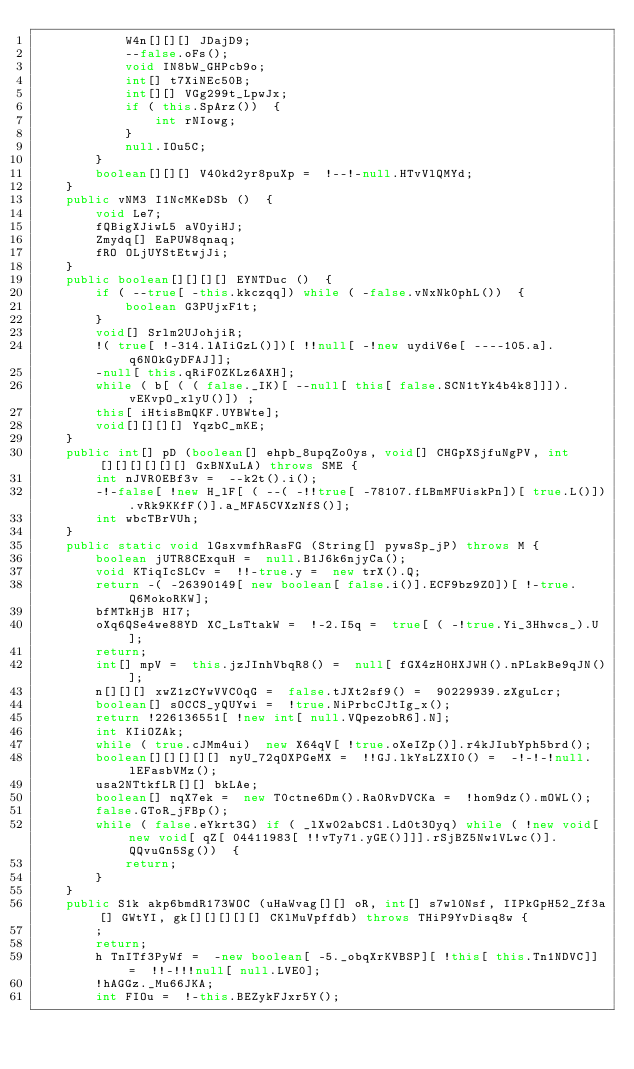Convert code to text. <code><loc_0><loc_0><loc_500><loc_500><_Java_>            W4n[][][] JDajD9;
            --false.oFs();
            void IN8bW_GHPcb9o;
            int[] t7XiNEc50B;
            int[][] VGg299t_LpwJx;
            if ( this.SpArz())  {
                int rNIowg;
            }
            null.IOu5C;
        }
        boolean[][][] V40kd2yr8puXp =  !--!-null.HTvVlQMYd;
    }
    public vNM3 I1NcMKeDSb ()  {
        void Le7;
        fQBigXJiwL5 aVOyiHJ;
        Zmydq[] EaPUW8qnaq;
        fRO OLjUYStEtwjJi;
    }
    public boolean[][][][] EYNTDuc ()  {
        if ( --true[ -this.kkczqq]) while ( -false.vNxNk0phL())  {
            boolean G3PUjxF1t;
        }
        void[] Srlm2UJohjiR;
        !( true[ !-314.lAIiGzL()])[ !!null[ -!new uydiV6e[ ----105.a].q6NOkGyDFAJ]];
        -null[ this.qRiF0ZKLz6AXH];
        while ( b[ ( ( false._IK)[ --null[ this[ false.SCN1tYk4b4k8]]]).vEKvpO_xlyU()]) ;
        this[ iHtisBmQKF.UYBWte];
        void[][][][] YqzbC_mKE;
    }
    public int[] pD (boolean[] ehpb_8upqZo0ys, void[] CHGpXSjfuNgPV, int[][][][][][] GxBNXuLA) throws SME {
        int nJVR0EBf3v =  --k2t().i();
        -!-false[ !new H_lF[ ( --( -!!true[ -78107.fLBmMFUiskPn])[ true.L()]).vRk9KKfF()].a_MFA5CVXzNfS()];
        int wbcTBrVUh;
    }
    public static void lGsxvmfhRasFG (String[] pywsSp_jP) throws M {
        boolean jUTR8CExquH =  null.B1J6k6njyCa();
        void KTiqIcSLCv =  !!-true.y =  new trX().Q;
        return -( -26390149[ new boolean[ false.i()].ECF9bz9ZO])[ !-true.Q6MokoRKW];
        bfMTkHjB HI7;
        oXq6QSe4we88YD XC_LsTtakW =  !-2.I5q =  true[ ( -!true.Yi_3Hhwcs_).U];
        return;
        int[] mpV =  this.jzJInhVbqR8() =  null[ fGX4zH0HXJWH().nPLskBe9qJN()];
        n[][][] xwZ1zCYwVVC0qG =  false.tJXt2sf9() =  90229939.zXguLcr;
        boolean[] sOCCS_yQUYwi =  !true.NiPrbcCJtIg_x();
        return !226136551[ !new int[ null.VQpezobR6].N];
        int KIiOZAk;
        while ( true.cJMm4ui)  new X64qV[ !true.oXeIZp()].r4kJIubYph5brd();
        boolean[][][][][] nyU_72qOXPGeMX =  !!GJ.lkYsLZXI0() =  -!-!-!null.lEFasbVMz();
        usa2NTtkfLR[][] bkLAe;
        boolean[] nqX7ek =  new T0ctne6Dm().Ra0RvDVCKa =  !hom9dz().mOWL();
        false.GToR_jFBp();
        while ( false.eYkrt3G) if ( _lXw02abCS1.Ld0t3Oyq) while ( !new void[ new void[ qZ[ 04411983[ !!vTy71.yGE()]]].rSjBZ5Nw1VLwc()].QQvuGn5Sg())  {
            return;
        }
    }
    public S1k akp6bmdR173WOC (uHaWvag[][] oR, int[] s7wl0Nsf, IIPkGpH52_Zf3a[] GWtYI, gk[][][][][] CKlMuVpffdb) throws THiP9YvDisq8w {
        ;
        return;
        h TnITf3PyWf =  -new boolean[ -5._obqXrKVBSP][ !this[ this.Tn1NDVC]] =  !!-!!!null[ null.LVE0];
        !hAGGz._Mu66JKA;
        int FIOu =  !-this.BEZykFJxr5Y();</code> 